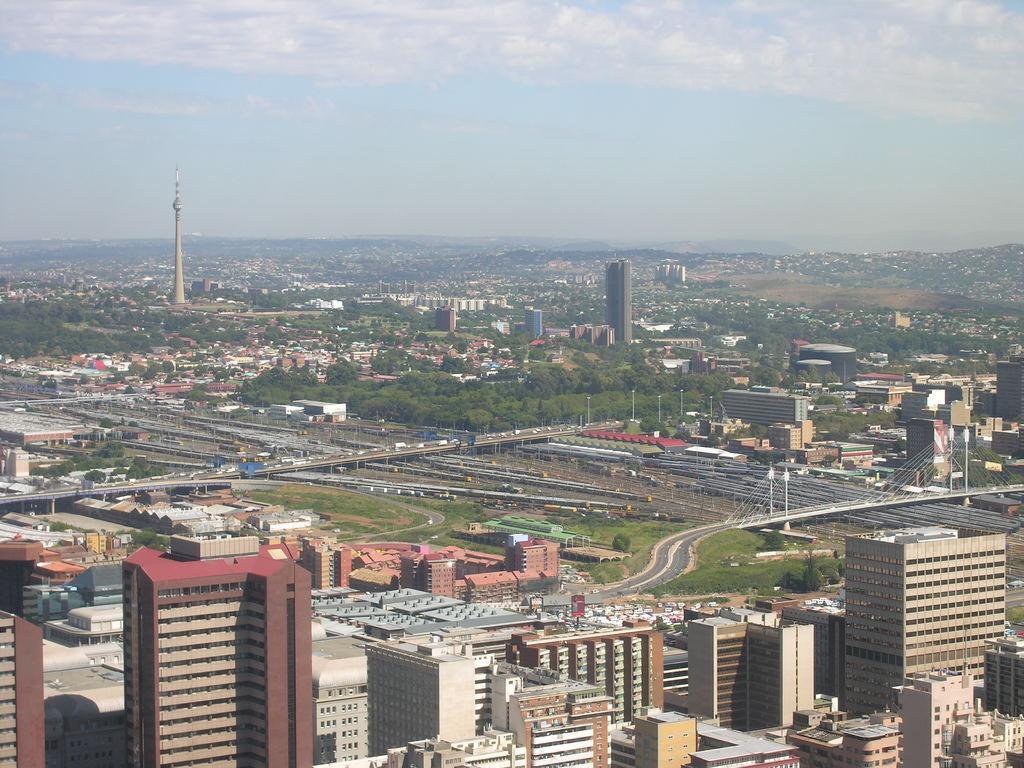How would you summarize this image in a sentence or two? This picture is clicked outside the city. At the bottom of the picture, we see buildings. In the middle of the picture, we see the road and bridges. We even see vehicles are moving on the road. There are trees, towers and buildings in the background. At the top, we see the sky and the clouds. 